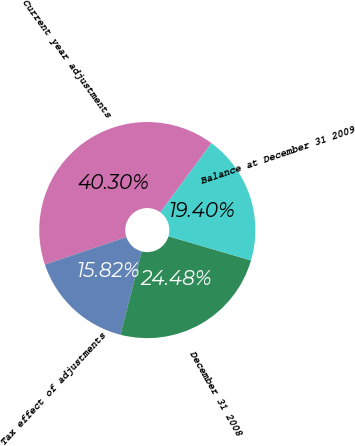Convert chart to OTSL. <chart><loc_0><loc_0><loc_500><loc_500><pie_chart><fcel>Current year adjustments<fcel>Tax effect of adjustments<fcel>December 31 2008<fcel>Balance at December 31 2009<nl><fcel>40.3%<fcel>15.82%<fcel>24.48%<fcel>19.4%<nl></chart> 